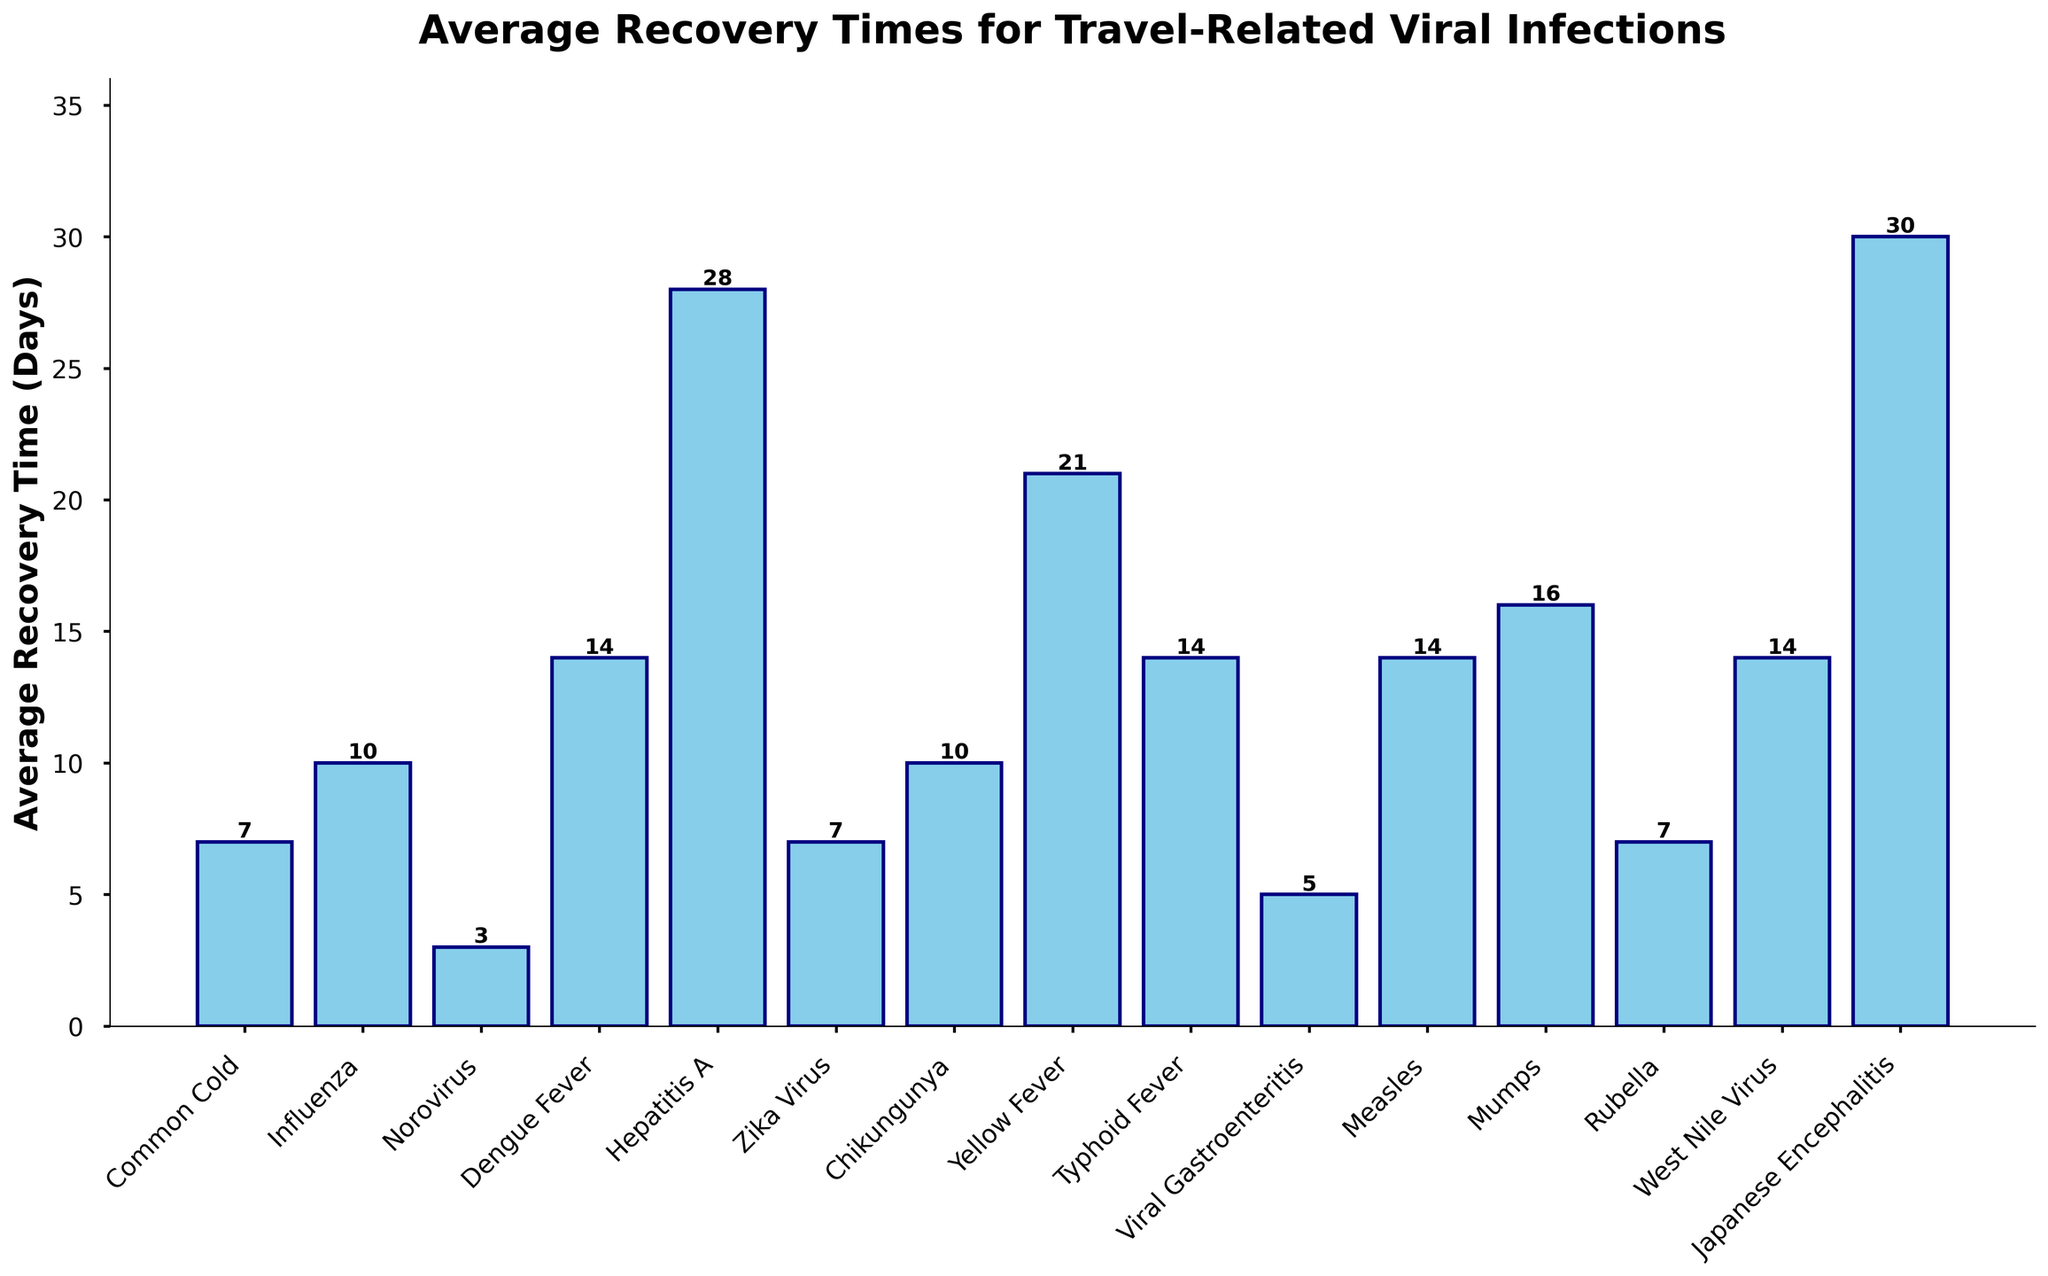What's the shortest recovery time among the infections listed? The shortest recovery time can be seen by identifying the shortest bar on the chart. In this case, Norovirus has the shortest recovery time at 3 days.
Answer: 3 days Which infection has the longest average recovery time? To find the infection with the longest recovery time, look for the tallest bar on the chart. Japanese Encephalitis has the longest recovery time at 30 days.
Answer: 30 days What is the difference in recovery time between Dengue Fever and Typhoid Fever? Compare the height of the bars for Dengue Fever (14 days) and Typhoid Fever (14 days). The difference is 0 days.
Answer: 0 days What is the average recovery time across all the listed infections? To find the average recovery time, sum all the recovery times and divide by the number of infections. (7 + 10 + 3 + 14 + 28 + 7 + 10 + 21 + 14 + 5 + 14 + 16 + 7 + 14 + 30) / 15 = 200/15 = 13.33 days
Answer: 13.33 days Which infections have the same recovery time and what is that time? Look for groups of bars with the same height. Dengue Fever, Typhoid Fever, Measles, and West Nile Virus all have a recovery time of 14 days. *Additionally, Influenza and Chikungunya both have a recovery time of 10 days; and Common Cold, Zika Virus, and Rubella all have a recovery time of 7 days*.
Answer: Dengue Fever, Typhoid Fever, Measles, West Nile Virus (14 days); Influenza, Chikungunya (10 days); Common Cold, Zika Virus, Rubella (7 days) What's the sum of the recovery times for all infections that last more than 20 days? Identify and add the recovery times of infections with bars taller than the 20-day marker. Hepatitis A (28 days), Yellow Fever (21 days), Japanese Encephalitis (30 days). So, 28 + 21 + 30 = 79 days.
Answer: 79 days How many infections have an average recovery time less than 10 days? Count the bars that are below the 10-day mark. Common Cold (7 days), Norovirus (3 days), Zika Virus (7 days), Viral Gastroenteritis (5 days), Rubella (7 days) = 5 infections.
Answer: 5 infections What is the combined recovery time for Common Cold, Influenza, and Measles? Add the recovery times of these specific infections. Common Cold (7 days), Influenza (10 days), Measles (14 days). So, 7 + 10 + 14 = 31 days.
Answer: 31 days What is the median recovery time for the infections listed? List the recovery times in ascending order: 3, 5, 7, 7, 7, 10, 10, 14, 14, 14, 14, 16, 21, 28, 30. The median value is the middle number in this ordered list, which is 14 days.
Answer: 14 days Which infection has an average recovery time closest to the overall average recovery time? Calculate the overall average recovery time (13.33 days) and find the infection with the recovery time closest to this. Infections with recovery times closest to 13.33 days are Dengue Fever, Typhoid Fever, Measles, and West Nile Virus each with 14 days.
Answer: Dengue Fever, Typhoid Fever, Measles, West Nile Virus 